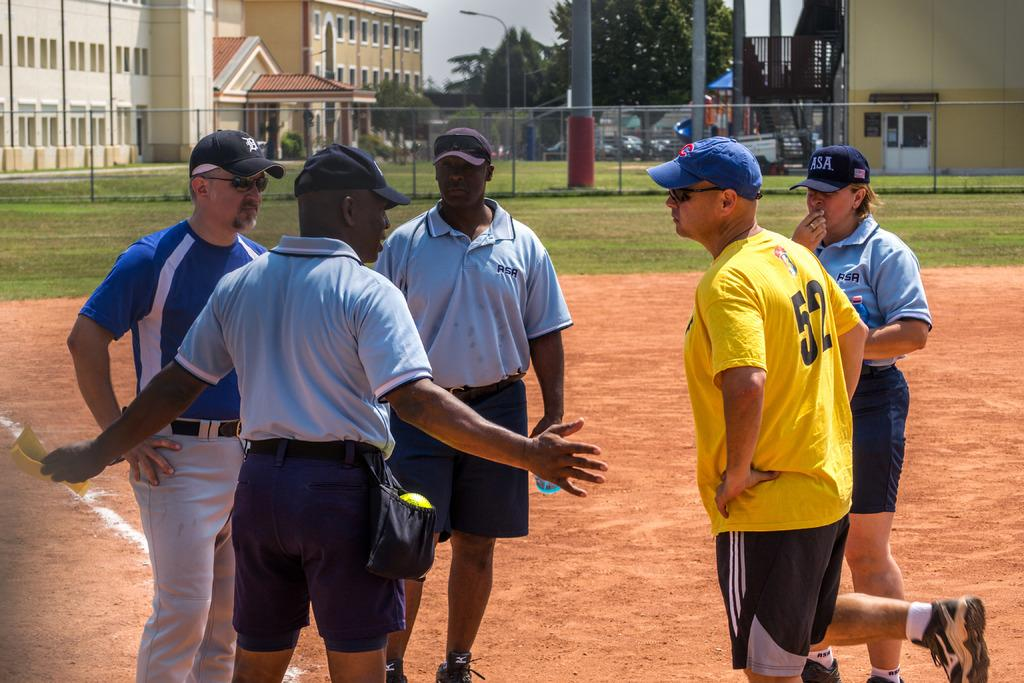<image>
Give a short and clear explanation of the subsequent image. a man in a yellow shirt that has the number 52 on it 